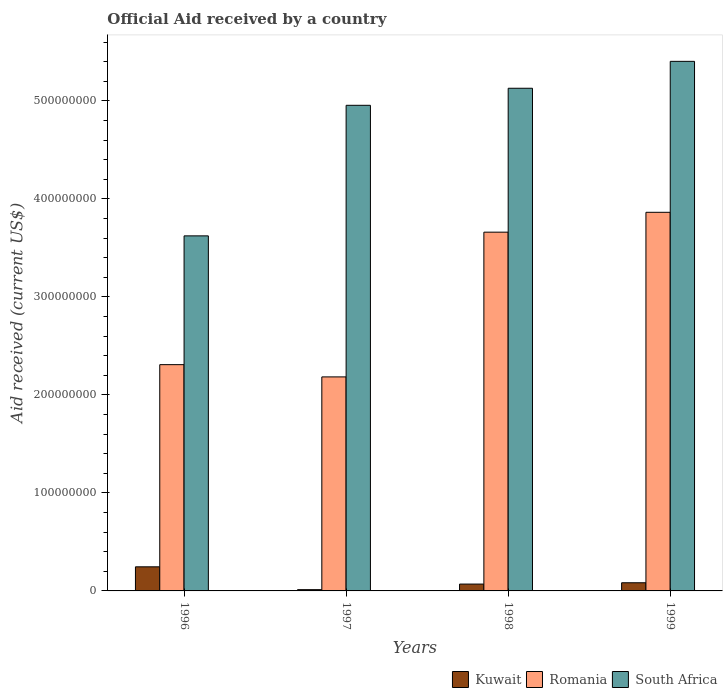How many groups of bars are there?
Offer a terse response. 4. How many bars are there on the 1st tick from the right?
Give a very brief answer. 3. What is the net official aid received in Kuwait in 1999?
Your answer should be compact. 8.33e+06. Across all years, what is the maximum net official aid received in Romania?
Give a very brief answer. 3.86e+08. Across all years, what is the minimum net official aid received in Romania?
Offer a very short reply. 2.18e+08. In which year was the net official aid received in Romania maximum?
Offer a terse response. 1999. In which year was the net official aid received in Kuwait minimum?
Keep it short and to the point. 1997. What is the total net official aid received in South Africa in the graph?
Your answer should be very brief. 1.91e+09. What is the difference between the net official aid received in Kuwait in 1996 and that in 1998?
Ensure brevity in your answer.  1.76e+07. What is the difference between the net official aid received in Kuwait in 1998 and the net official aid received in Romania in 1999?
Keep it short and to the point. -3.79e+08. What is the average net official aid received in South Africa per year?
Provide a short and direct response. 4.78e+08. In the year 1999, what is the difference between the net official aid received in South Africa and net official aid received in Romania?
Give a very brief answer. 1.54e+08. In how many years, is the net official aid received in Kuwait greater than 60000000 US$?
Make the answer very short. 0. What is the ratio of the net official aid received in Kuwait in 1998 to that in 1999?
Your response must be concise. 0.84. Is the net official aid received in Romania in 1997 less than that in 1999?
Offer a terse response. Yes. Is the difference between the net official aid received in South Africa in 1996 and 1999 greater than the difference between the net official aid received in Romania in 1996 and 1999?
Your answer should be very brief. No. What is the difference between the highest and the second highest net official aid received in Kuwait?
Your answer should be compact. 1.63e+07. What is the difference between the highest and the lowest net official aid received in South Africa?
Make the answer very short. 1.78e+08. Is the sum of the net official aid received in Romania in 1998 and 1999 greater than the maximum net official aid received in South Africa across all years?
Give a very brief answer. Yes. What does the 1st bar from the left in 1996 represents?
Make the answer very short. Kuwait. What does the 3rd bar from the right in 1996 represents?
Provide a succinct answer. Kuwait. Is it the case that in every year, the sum of the net official aid received in Kuwait and net official aid received in South Africa is greater than the net official aid received in Romania?
Ensure brevity in your answer.  Yes. What is the difference between two consecutive major ticks on the Y-axis?
Provide a succinct answer. 1.00e+08. Does the graph contain grids?
Provide a short and direct response. No. How many legend labels are there?
Keep it short and to the point. 3. What is the title of the graph?
Your answer should be very brief. Official Aid received by a country. What is the label or title of the Y-axis?
Provide a short and direct response. Aid received (current US$). What is the Aid received (current US$) of Kuwait in 1996?
Your answer should be very brief. 2.46e+07. What is the Aid received (current US$) in Romania in 1996?
Offer a very short reply. 2.31e+08. What is the Aid received (current US$) in South Africa in 1996?
Provide a short and direct response. 3.62e+08. What is the Aid received (current US$) in Kuwait in 1997?
Your answer should be compact. 1.28e+06. What is the Aid received (current US$) of Romania in 1997?
Ensure brevity in your answer.  2.18e+08. What is the Aid received (current US$) in South Africa in 1997?
Keep it short and to the point. 4.96e+08. What is the Aid received (current US$) in Kuwait in 1998?
Offer a terse response. 6.99e+06. What is the Aid received (current US$) of Romania in 1998?
Give a very brief answer. 3.66e+08. What is the Aid received (current US$) of South Africa in 1998?
Your answer should be very brief. 5.13e+08. What is the Aid received (current US$) in Kuwait in 1999?
Offer a terse response. 8.33e+06. What is the Aid received (current US$) of Romania in 1999?
Your answer should be very brief. 3.86e+08. What is the Aid received (current US$) in South Africa in 1999?
Make the answer very short. 5.40e+08. Across all years, what is the maximum Aid received (current US$) in Kuwait?
Your answer should be compact. 2.46e+07. Across all years, what is the maximum Aid received (current US$) of Romania?
Provide a succinct answer. 3.86e+08. Across all years, what is the maximum Aid received (current US$) in South Africa?
Give a very brief answer. 5.40e+08. Across all years, what is the minimum Aid received (current US$) in Kuwait?
Provide a succinct answer. 1.28e+06. Across all years, what is the minimum Aid received (current US$) of Romania?
Provide a succinct answer. 2.18e+08. Across all years, what is the minimum Aid received (current US$) of South Africa?
Ensure brevity in your answer.  3.62e+08. What is the total Aid received (current US$) in Kuwait in the graph?
Ensure brevity in your answer.  4.12e+07. What is the total Aid received (current US$) in Romania in the graph?
Keep it short and to the point. 1.20e+09. What is the total Aid received (current US$) of South Africa in the graph?
Ensure brevity in your answer.  1.91e+09. What is the difference between the Aid received (current US$) of Kuwait in 1996 and that in 1997?
Provide a succinct answer. 2.33e+07. What is the difference between the Aid received (current US$) in Romania in 1996 and that in 1997?
Provide a short and direct response. 1.25e+07. What is the difference between the Aid received (current US$) in South Africa in 1996 and that in 1997?
Your response must be concise. -1.33e+08. What is the difference between the Aid received (current US$) of Kuwait in 1996 and that in 1998?
Offer a very short reply. 1.76e+07. What is the difference between the Aid received (current US$) of Romania in 1996 and that in 1998?
Give a very brief answer. -1.35e+08. What is the difference between the Aid received (current US$) of South Africa in 1996 and that in 1998?
Your answer should be compact. -1.51e+08. What is the difference between the Aid received (current US$) in Kuwait in 1996 and that in 1999?
Your answer should be very brief. 1.63e+07. What is the difference between the Aid received (current US$) of Romania in 1996 and that in 1999?
Ensure brevity in your answer.  -1.55e+08. What is the difference between the Aid received (current US$) in South Africa in 1996 and that in 1999?
Provide a succinct answer. -1.78e+08. What is the difference between the Aid received (current US$) of Kuwait in 1997 and that in 1998?
Provide a succinct answer. -5.71e+06. What is the difference between the Aid received (current US$) of Romania in 1997 and that in 1998?
Give a very brief answer. -1.48e+08. What is the difference between the Aid received (current US$) of South Africa in 1997 and that in 1998?
Your answer should be compact. -1.74e+07. What is the difference between the Aid received (current US$) in Kuwait in 1997 and that in 1999?
Your answer should be compact. -7.05e+06. What is the difference between the Aid received (current US$) in Romania in 1997 and that in 1999?
Provide a succinct answer. -1.68e+08. What is the difference between the Aid received (current US$) in South Africa in 1997 and that in 1999?
Provide a short and direct response. -4.48e+07. What is the difference between the Aid received (current US$) in Kuwait in 1998 and that in 1999?
Your response must be concise. -1.34e+06. What is the difference between the Aid received (current US$) in Romania in 1998 and that in 1999?
Provide a short and direct response. -2.03e+07. What is the difference between the Aid received (current US$) of South Africa in 1998 and that in 1999?
Your answer should be compact. -2.75e+07. What is the difference between the Aid received (current US$) in Kuwait in 1996 and the Aid received (current US$) in Romania in 1997?
Provide a short and direct response. -1.94e+08. What is the difference between the Aid received (current US$) of Kuwait in 1996 and the Aid received (current US$) of South Africa in 1997?
Offer a very short reply. -4.71e+08. What is the difference between the Aid received (current US$) of Romania in 1996 and the Aid received (current US$) of South Africa in 1997?
Make the answer very short. -2.65e+08. What is the difference between the Aid received (current US$) in Kuwait in 1996 and the Aid received (current US$) in Romania in 1998?
Make the answer very short. -3.42e+08. What is the difference between the Aid received (current US$) of Kuwait in 1996 and the Aid received (current US$) of South Africa in 1998?
Ensure brevity in your answer.  -4.88e+08. What is the difference between the Aid received (current US$) of Romania in 1996 and the Aid received (current US$) of South Africa in 1998?
Your answer should be very brief. -2.82e+08. What is the difference between the Aid received (current US$) of Kuwait in 1996 and the Aid received (current US$) of Romania in 1999?
Offer a terse response. -3.62e+08. What is the difference between the Aid received (current US$) in Kuwait in 1996 and the Aid received (current US$) in South Africa in 1999?
Provide a short and direct response. -5.16e+08. What is the difference between the Aid received (current US$) of Romania in 1996 and the Aid received (current US$) of South Africa in 1999?
Ensure brevity in your answer.  -3.10e+08. What is the difference between the Aid received (current US$) in Kuwait in 1997 and the Aid received (current US$) in Romania in 1998?
Your answer should be very brief. -3.65e+08. What is the difference between the Aid received (current US$) in Kuwait in 1997 and the Aid received (current US$) in South Africa in 1998?
Ensure brevity in your answer.  -5.12e+08. What is the difference between the Aid received (current US$) of Romania in 1997 and the Aid received (current US$) of South Africa in 1998?
Offer a terse response. -2.95e+08. What is the difference between the Aid received (current US$) in Kuwait in 1997 and the Aid received (current US$) in Romania in 1999?
Offer a terse response. -3.85e+08. What is the difference between the Aid received (current US$) of Kuwait in 1997 and the Aid received (current US$) of South Africa in 1999?
Make the answer very short. -5.39e+08. What is the difference between the Aid received (current US$) in Romania in 1997 and the Aid received (current US$) in South Africa in 1999?
Your answer should be very brief. -3.22e+08. What is the difference between the Aid received (current US$) in Kuwait in 1998 and the Aid received (current US$) in Romania in 1999?
Provide a short and direct response. -3.79e+08. What is the difference between the Aid received (current US$) in Kuwait in 1998 and the Aid received (current US$) in South Africa in 1999?
Your answer should be compact. -5.33e+08. What is the difference between the Aid received (current US$) of Romania in 1998 and the Aid received (current US$) of South Africa in 1999?
Provide a short and direct response. -1.74e+08. What is the average Aid received (current US$) in Kuwait per year?
Your response must be concise. 1.03e+07. What is the average Aid received (current US$) in Romania per year?
Offer a very short reply. 3.00e+08. What is the average Aid received (current US$) in South Africa per year?
Provide a short and direct response. 4.78e+08. In the year 1996, what is the difference between the Aid received (current US$) of Kuwait and Aid received (current US$) of Romania?
Offer a very short reply. -2.06e+08. In the year 1996, what is the difference between the Aid received (current US$) of Kuwait and Aid received (current US$) of South Africa?
Offer a very short reply. -3.38e+08. In the year 1996, what is the difference between the Aid received (current US$) of Romania and Aid received (current US$) of South Africa?
Ensure brevity in your answer.  -1.31e+08. In the year 1997, what is the difference between the Aid received (current US$) of Kuwait and Aid received (current US$) of Romania?
Your answer should be very brief. -2.17e+08. In the year 1997, what is the difference between the Aid received (current US$) of Kuwait and Aid received (current US$) of South Africa?
Offer a very short reply. -4.94e+08. In the year 1997, what is the difference between the Aid received (current US$) of Romania and Aid received (current US$) of South Africa?
Your answer should be compact. -2.77e+08. In the year 1998, what is the difference between the Aid received (current US$) of Kuwait and Aid received (current US$) of Romania?
Offer a very short reply. -3.59e+08. In the year 1998, what is the difference between the Aid received (current US$) of Kuwait and Aid received (current US$) of South Africa?
Make the answer very short. -5.06e+08. In the year 1998, what is the difference between the Aid received (current US$) of Romania and Aid received (current US$) of South Africa?
Give a very brief answer. -1.47e+08. In the year 1999, what is the difference between the Aid received (current US$) of Kuwait and Aid received (current US$) of Romania?
Your answer should be compact. -3.78e+08. In the year 1999, what is the difference between the Aid received (current US$) in Kuwait and Aid received (current US$) in South Africa?
Your answer should be very brief. -5.32e+08. In the year 1999, what is the difference between the Aid received (current US$) of Romania and Aid received (current US$) of South Africa?
Your answer should be very brief. -1.54e+08. What is the ratio of the Aid received (current US$) in Kuwait in 1996 to that in 1997?
Give a very brief answer. 19.22. What is the ratio of the Aid received (current US$) of Romania in 1996 to that in 1997?
Provide a succinct answer. 1.06. What is the ratio of the Aid received (current US$) of South Africa in 1996 to that in 1997?
Give a very brief answer. 0.73. What is the ratio of the Aid received (current US$) of Kuwait in 1996 to that in 1998?
Give a very brief answer. 3.52. What is the ratio of the Aid received (current US$) of Romania in 1996 to that in 1998?
Ensure brevity in your answer.  0.63. What is the ratio of the Aid received (current US$) in South Africa in 1996 to that in 1998?
Your answer should be compact. 0.71. What is the ratio of the Aid received (current US$) of Kuwait in 1996 to that in 1999?
Ensure brevity in your answer.  2.95. What is the ratio of the Aid received (current US$) of Romania in 1996 to that in 1999?
Make the answer very short. 0.6. What is the ratio of the Aid received (current US$) of South Africa in 1996 to that in 1999?
Make the answer very short. 0.67. What is the ratio of the Aid received (current US$) in Kuwait in 1997 to that in 1998?
Your answer should be very brief. 0.18. What is the ratio of the Aid received (current US$) of Romania in 1997 to that in 1998?
Your answer should be compact. 0.6. What is the ratio of the Aid received (current US$) in South Africa in 1997 to that in 1998?
Make the answer very short. 0.97. What is the ratio of the Aid received (current US$) of Kuwait in 1997 to that in 1999?
Your answer should be compact. 0.15. What is the ratio of the Aid received (current US$) of Romania in 1997 to that in 1999?
Provide a short and direct response. 0.57. What is the ratio of the Aid received (current US$) in South Africa in 1997 to that in 1999?
Offer a very short reply. 0.92. What is the ratio of the Aid received (current US$) in Kuwait in 1998 to that in 1999?
Provide a succinct answer. 0.84. What is the ratio of the Aid received (current US$) of Romania in 1998 to that in 1999?
Offer a very short reply. 0.95. What is the ratio of the Aid received (current US$) of South Africa in 1998 to that in 1999?
Keep it short and to the point. 0.95. What is the difference between the highest and the second highest Aid received (current US$) in Kuwait?
Your response must be concise. 1.63e+07. What is the difference between the highest and the second highest Aid received (current US$) of Romania?
Offer a terse response. 2.03e+07. What is the difference between the highest and the second highest Aid received (current US$) of South Africa?
Your answer should be very brief. 2.75e+07. What is the difference between the highest and the lowest Aid received (current US$) of Kuwait?
Offer a very short reply. 2.33e+07. What is the difference between the highest and the lowest Aid received (current US$) of Romania?
Offer a terse response. 1.68e+08. What is the difference between the highest and the lowest Aid received (current US$) in South Africa?
Keep it short and to the point. 1.78e+08. 